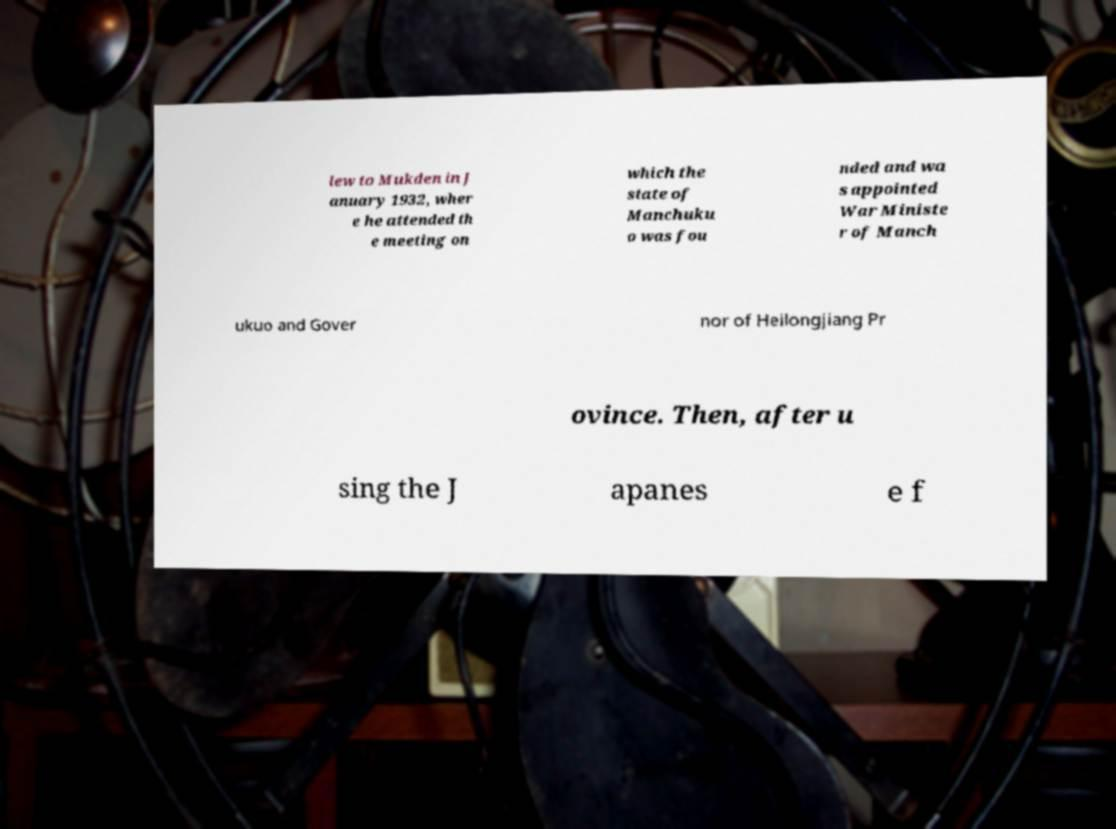Please identify and transcribe the text found in this image. lew to Mukden in J anuary 1932, wher e he attended th e meeting on which the state of Manchuku o was fou nded and wa s appointed War Ministe r of Manch ukuo and Gover nor of Heilongjiang Pr ovince. Then, after u sing the J apanes e f 